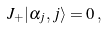Convert formula to latex. <formula><loc_0><loc_0><loc_500><loc_500>J _ { + } | \alpha _ { j } , j \rangle = 0 \, ,</formula> 